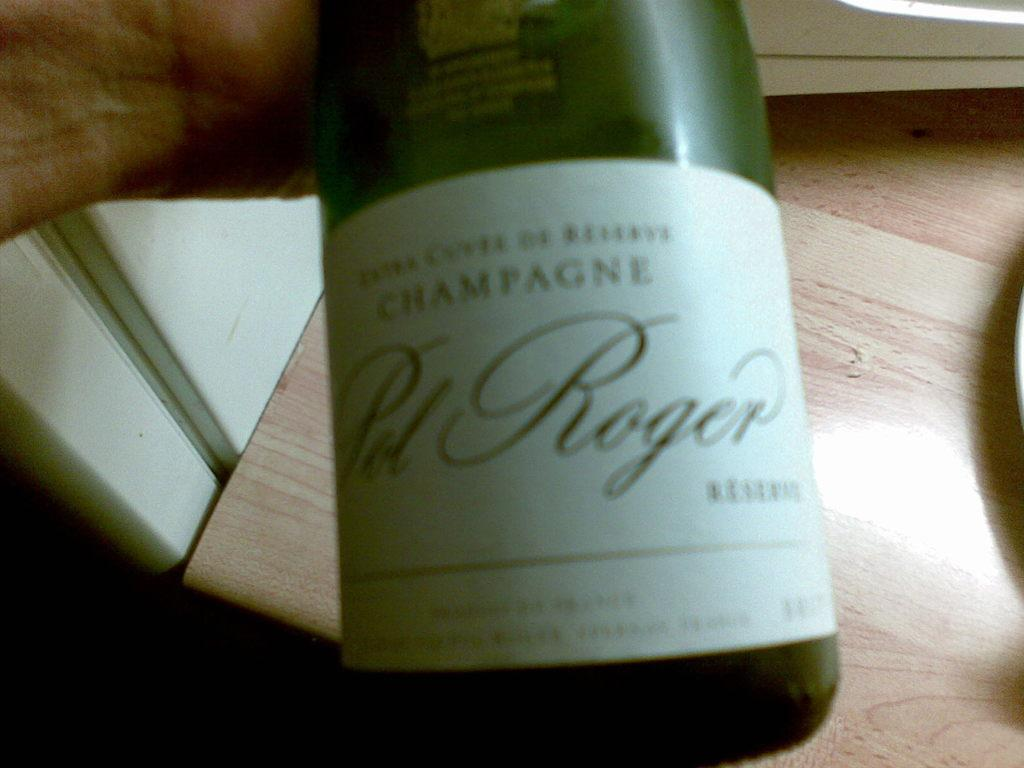<image>
Write a terse but informative summary of the picture. Green bottle with a white label that says "ROGER" on it. 